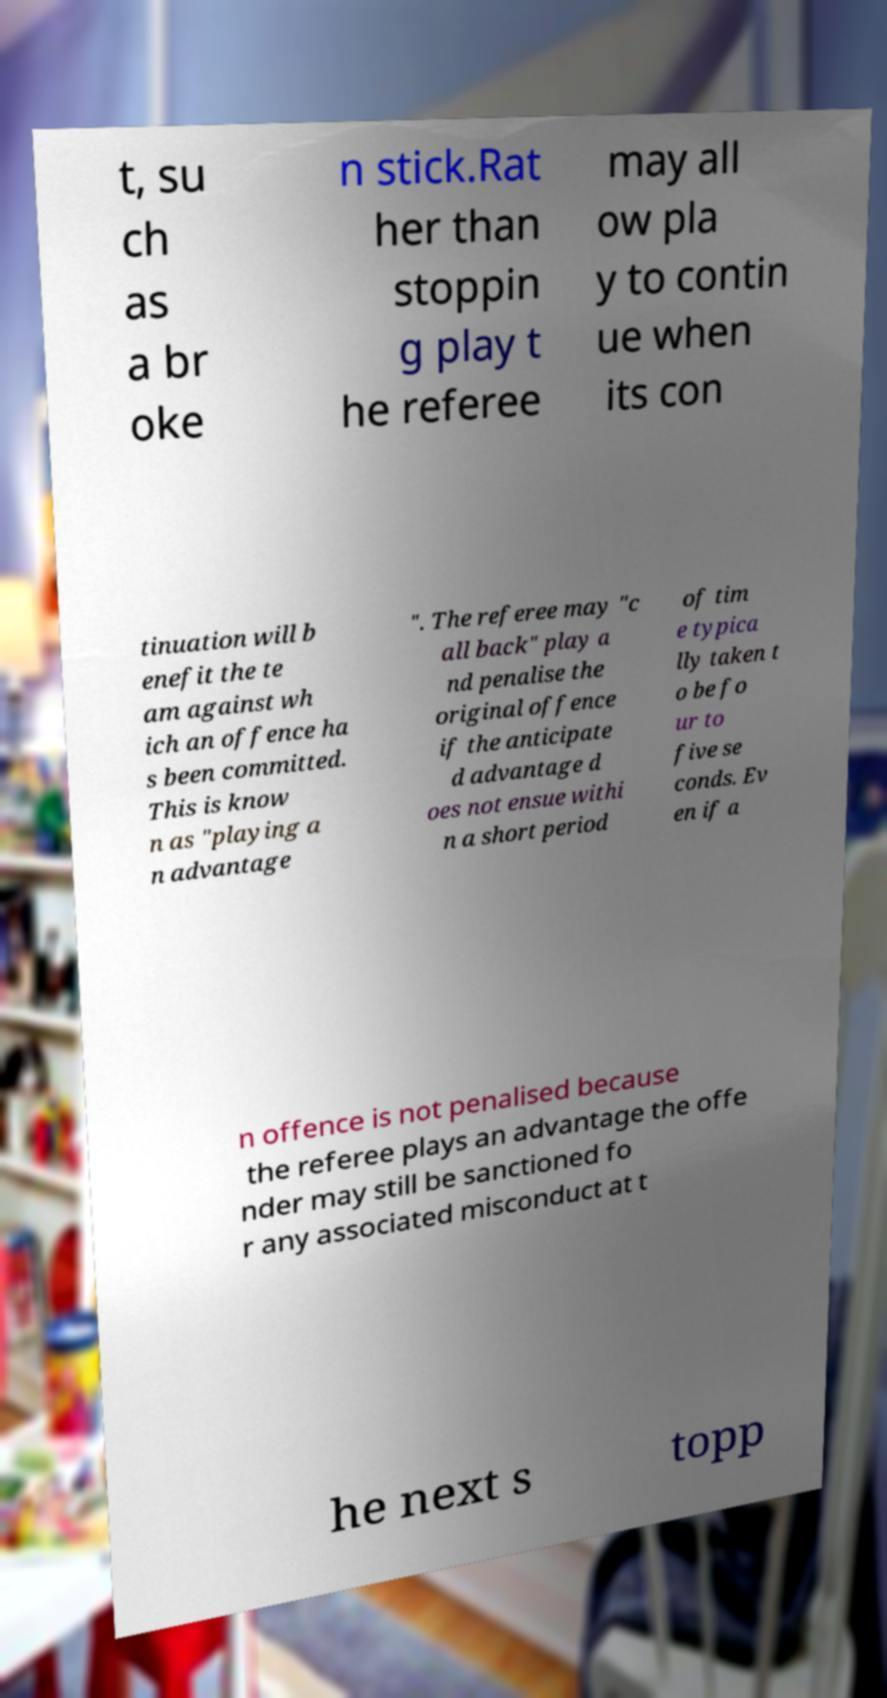Could you assist in decoding the text presented in this image and type it out clearly? t, su ch as a br oke n stick.Rat her than stoppin g play t he referee may all ow pla y to contin ue when its con tinuation will b enefit the te am against wh ich an offence ha s been committed. This is know n as "playing a n advantage ". The referee may "c all back" play a nd penalise the original offence if the anticipate d advantage d oes not ensue withi n a short period of tim e typica lly taken t o be fo ur to five se conds. Ev en if a n offence is not penalised because the referee plays an advantage the offe nder may still be sanctioned fo r any associated misconduct at t he next s topp 